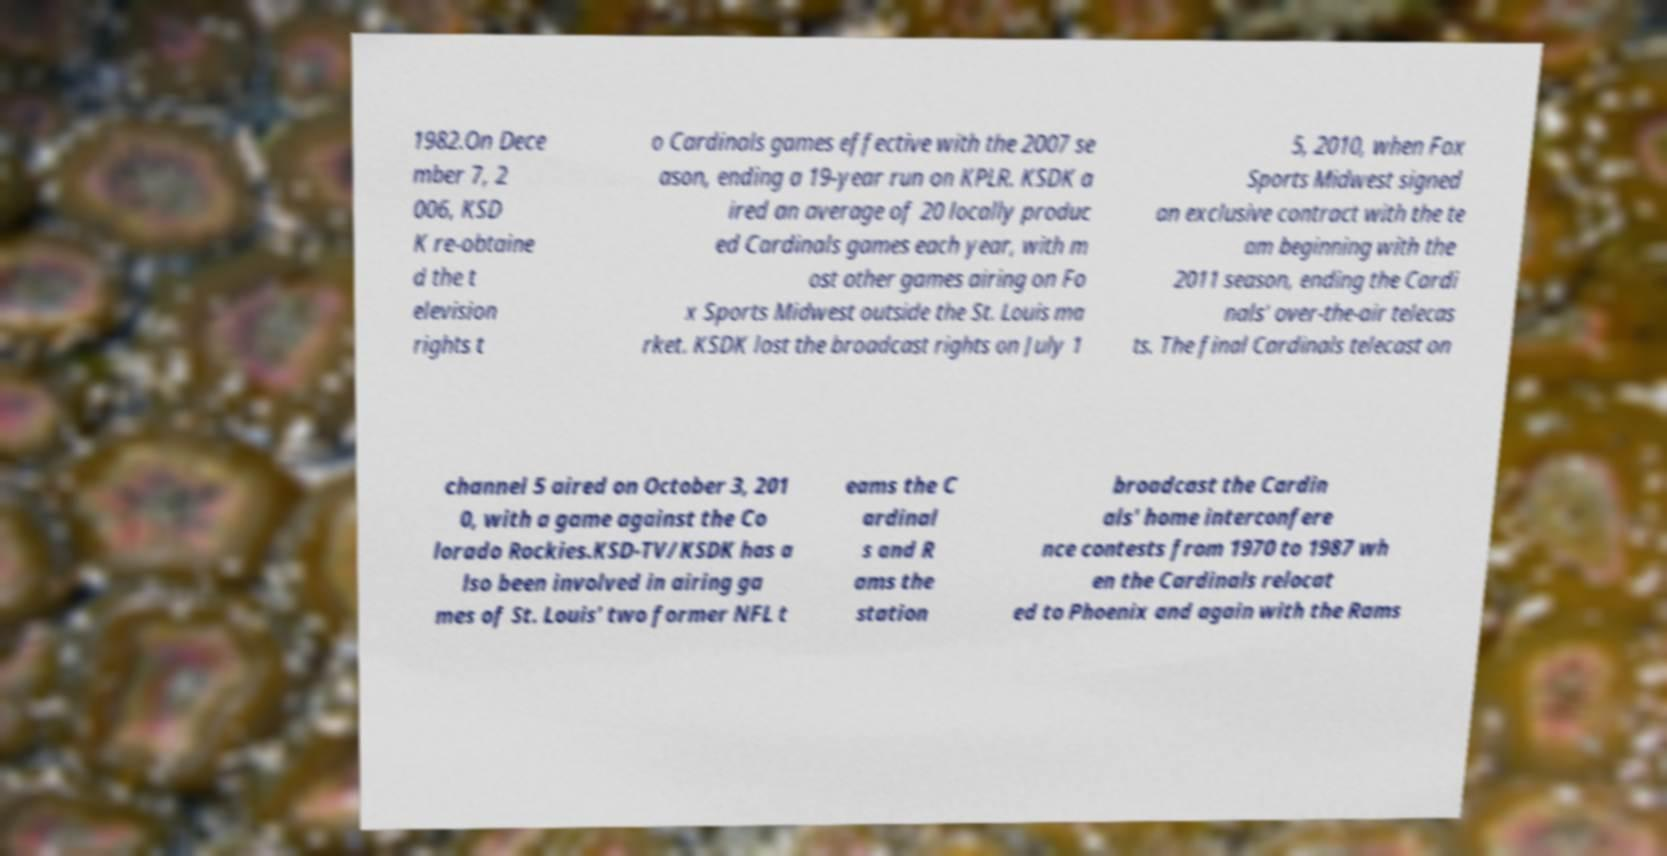Could you assist in decoding the text presented in this image and type it out clearly? 1982.On Dece mber 7, 2 006, KSD K re-obtaine d the t elevision rights t o Cardinals games effective with the 2007 se ason, ending a 19-year run on KPLR. KSDK a ired an average of 20 locally produc ed Cardinals games each year, with m ost other games airing on Fo x Sports Midwest outside the St. Louis ma rket. KSDK lost the broadcast rights on July 1 5, 2010, when Fox Sports Midwest signed an exclusive contract with the te am beginning with the 2011 season, ending the Cardi nals' over-the-air telecas ts. The final Cardinals telecast on channel 5 aired on October 3, 201 0, with a game against the Co lorado Rockies.KSD-TV/KSDK has a lso been involved in airing ga mes of St. Louis' two former NFL t eams the C ardinal s and R ams the station broadcast the Cardin als' home interconfere nce contests from 1970 to 1987 wh en the Cardinals relocat ed to Phoenix and again with the Rams 